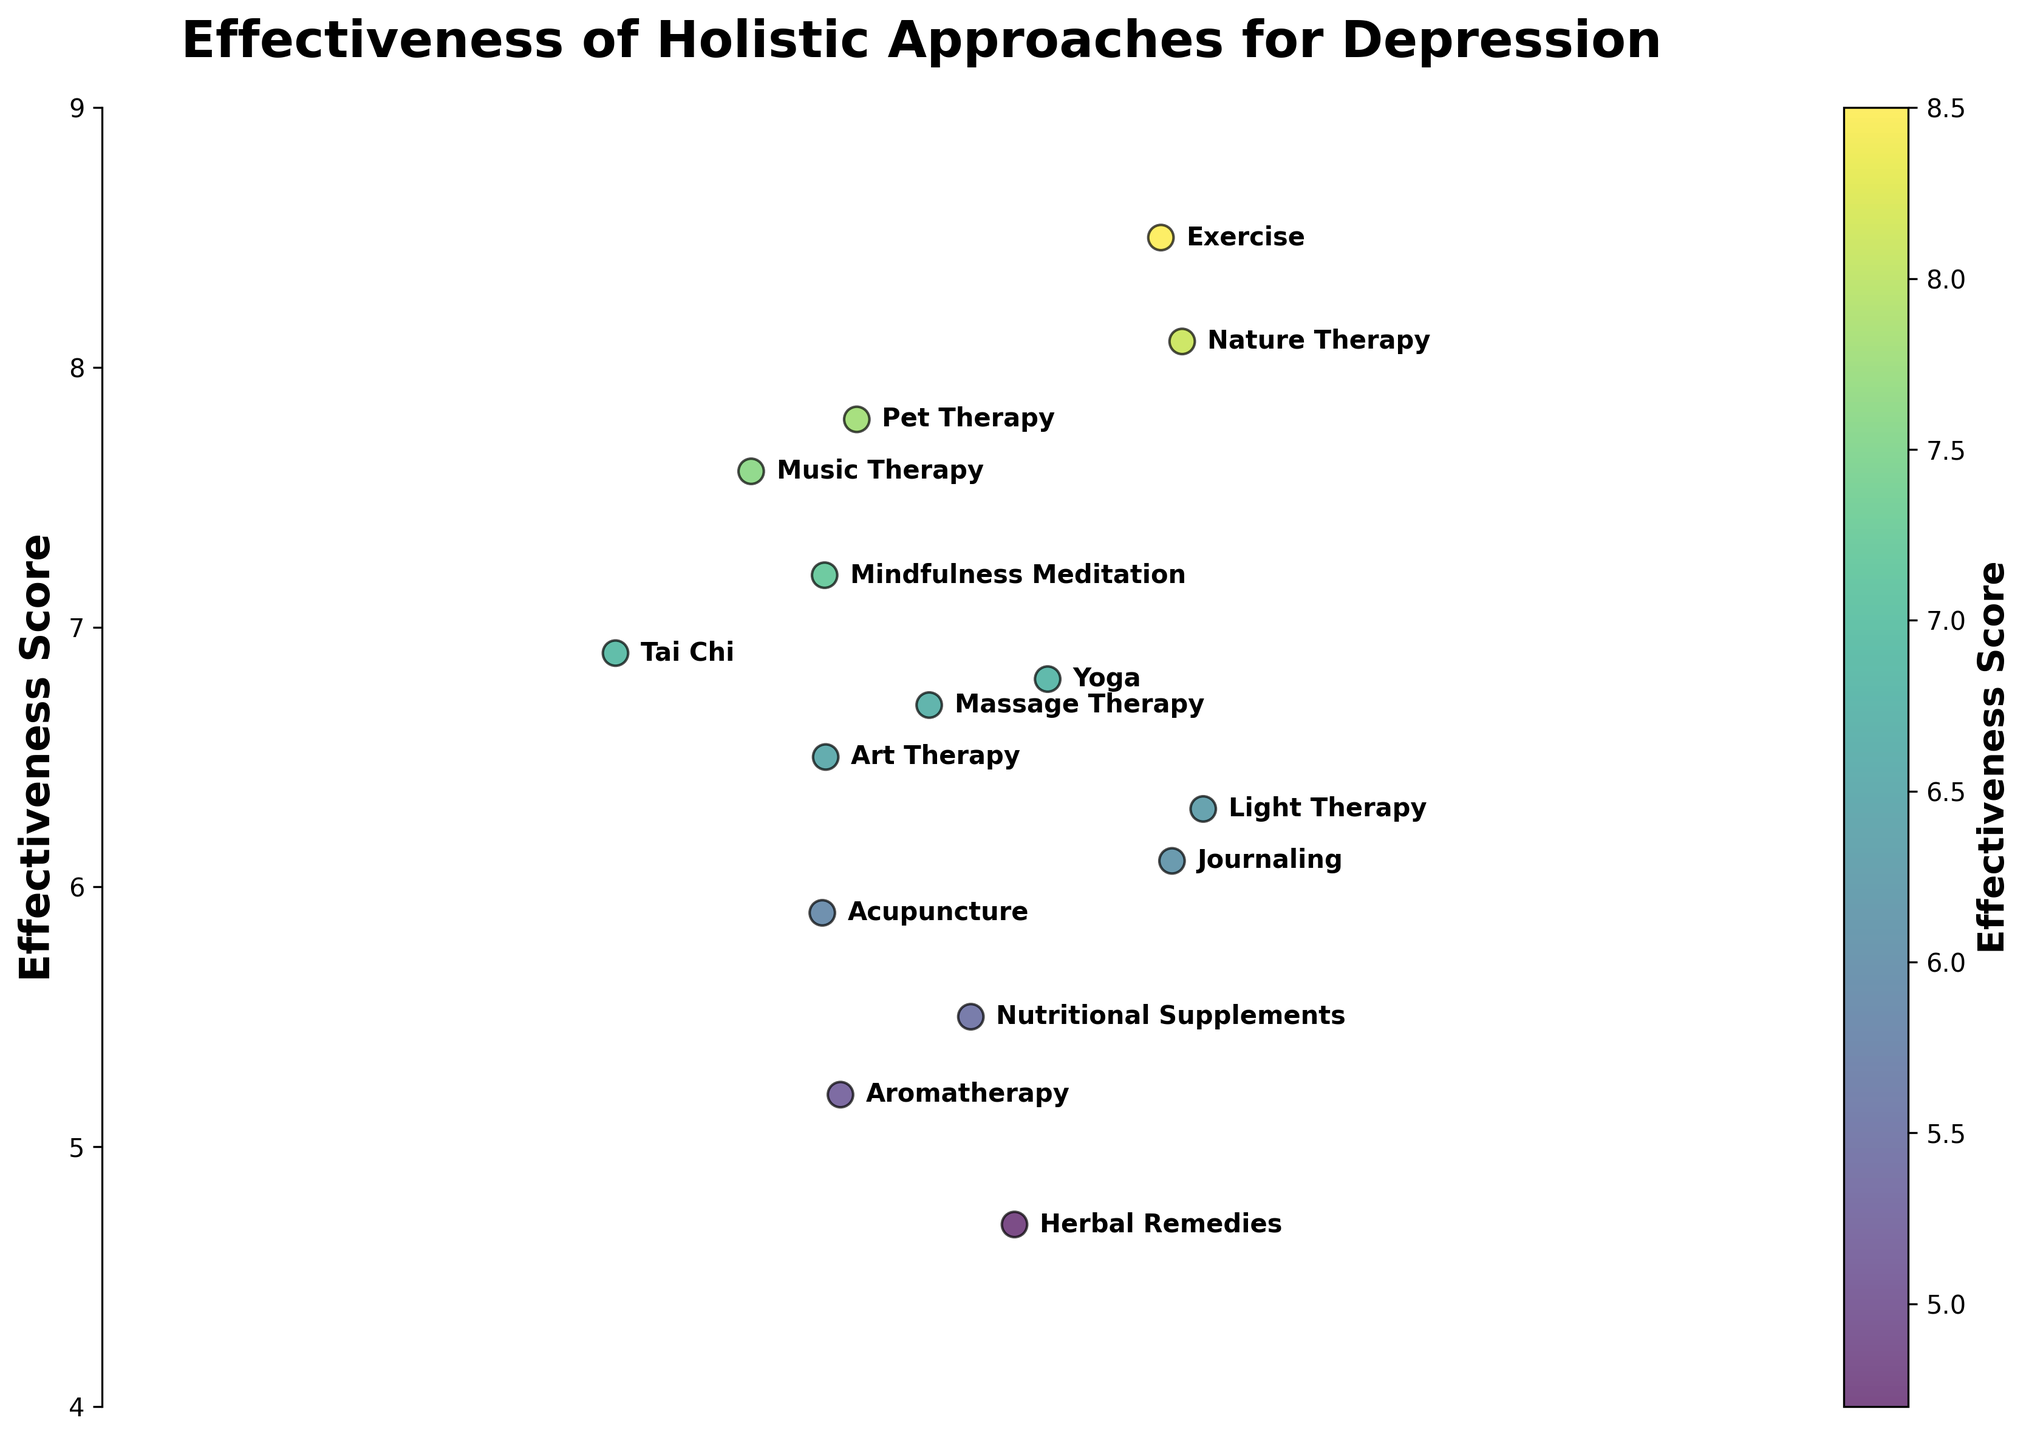What's the title of the figure? The title of the figure is located at the top, in bold and large font. By reading it, you can find out what the figure is about.
Answer: Effectiveness of Holistic Approaches for Depression How many holistic approaches are presented in the figure? The figure contains an annotated label for each approach next to the corresponding scatter point. By counting these annotations, you can determine the number of approaches.
Answer: 15 Which holistic approach has the highest effectiveness score? To find the answer, look for the scatter point that is positioned at the highest y-axis value. Then, refer to the annotation next to that point.
Answer: Exercise What's the average effectiveness score of the approaches? Sum all effectiveness scores (7.2 + 6.8 + 8.1 + 6.5 + 5.9 + 4.7 + 8.5 + 6.3 + 7.6 + 5.2 + 6.9 + 5.5 + 7.8 + 6.1 + 6.7) and divide by the number of approaches (15).
Answer: 6.65 Which approach has an effectiveness score closest to the mean score? First, calculate the average effectiveness score. Then, find the approach whose score is the closest to this mean.
Answer: Journaling How many approaches have an effectiveness score above 7? Examine the y-axis values and count the scatter points that are above the value of 7, referring to the annotations for corresponding names.
Answer: 6 Is there any approach with an effectiveness score below 5? Observe the scatter points below the y-axis value of 5 and check the annotations to see if there are corresponding approaches.
Answer: Yes, Herbal Remedies Which two approaches have effectiveness scores that are closest to each other? Find pairs of scatter points that are very close in terms of their y-axis values and then check their associated annotations.
Answer: Mindfulness Meditation and Music Therapy Which holistic approach has the lowest effectiveness score? Look for the scatter point on the lowest y-axis value and refer to its corresponding annotation to identify the approach.
Answer: Herbal Remedies What is the effectiveness score range for the approaches? Subtract the lowest effectiveness score from the highest score to find the range. The lowest score is 4.7 (Herbal Remedies) and the highest is 8.5 (Exercise).
Answer: 3.8 